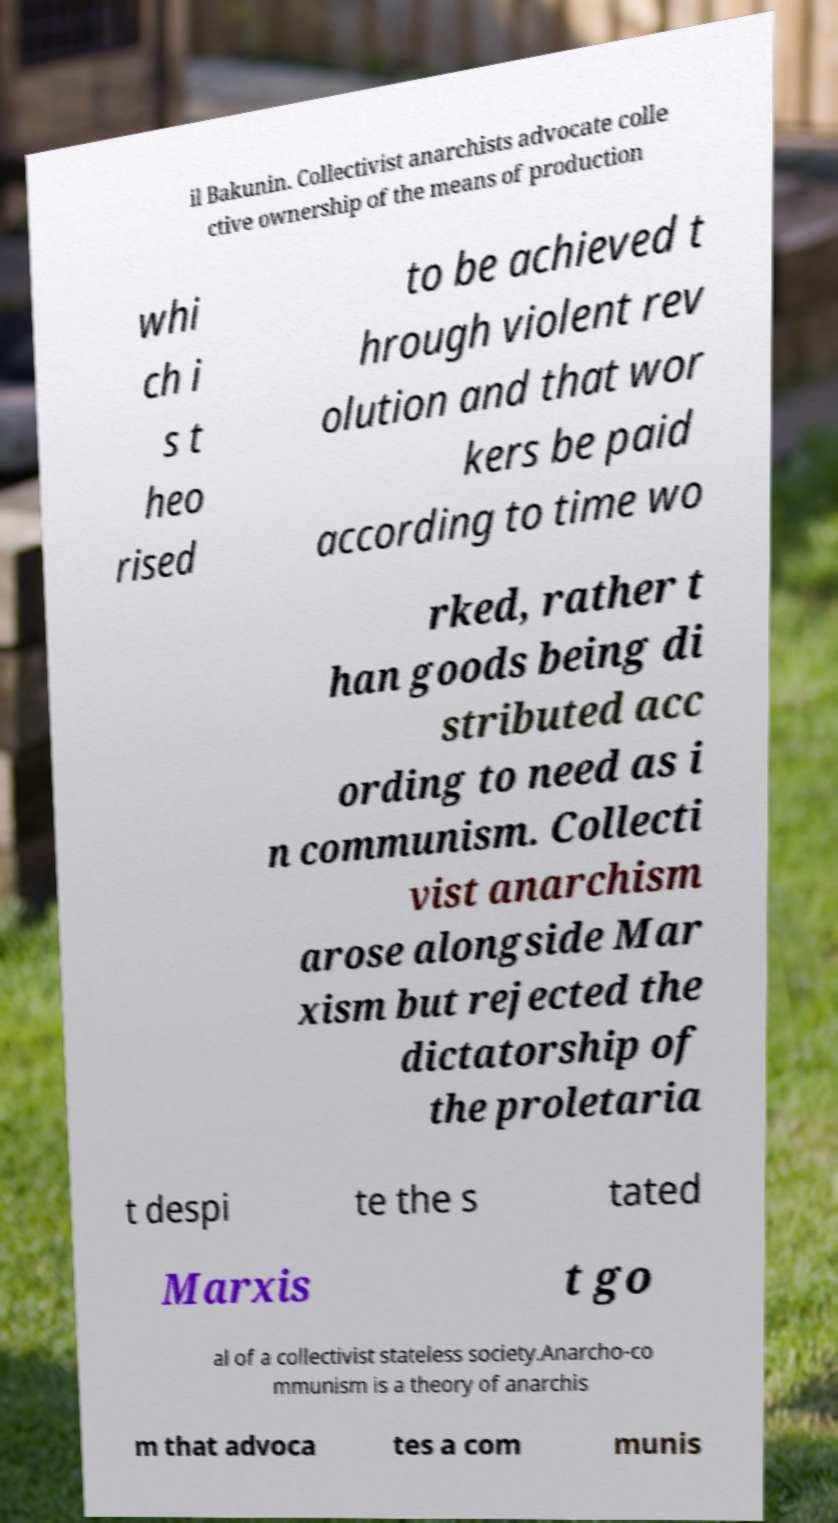Could you extract and type out the text from this image? il Bakunin. Collectivist anarchists advocate colle ctive ownership of the means of production whi ch i s t heo rised to be achieved t hrough violent rev olution and that wor kers be paid according to time wo rked, rather t han goods being di stributed acc ording to need as i n communism. Collecti vist anarchism arose alongside Mar xism but rejected the dictatorship of the proletaria t despi te the s tated Marxis t go al of a collectivist stateless society.Anarcho-co mmunism is a theory of anarchis m that advoca tes a com munis 